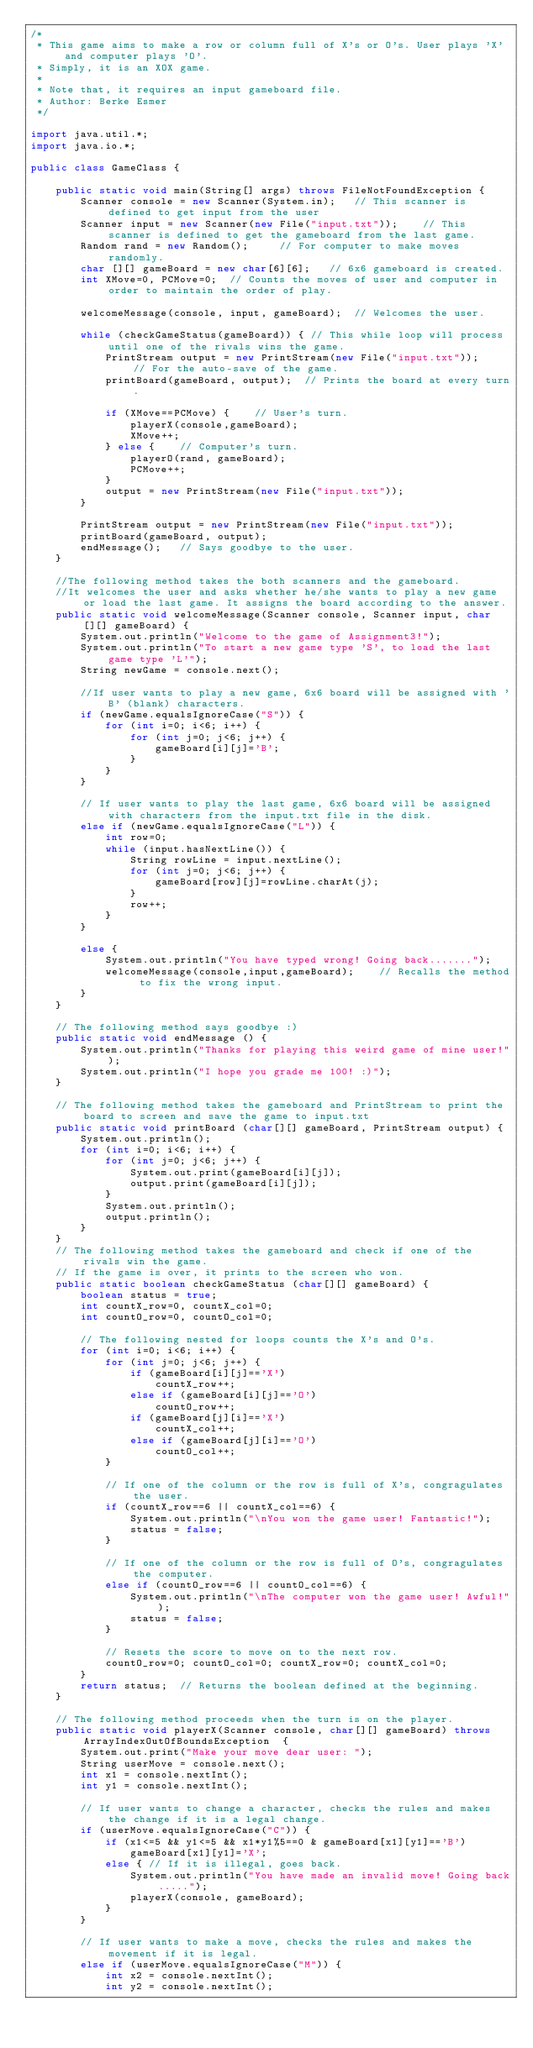<code> <loc_0><loc_0><loc_500><loc_500><_Java_>/*
 * This game aims to make a row or column full of X's or O's. User plays 'X' and computer plays 'O'.
 * Simply, it is an XOX game.
 *
 * Note that, it requires an input gameboard file.
 * Author: Berke Esmer
 */

import java.util.*;
import java.io.*;

public class GameClass {

    public static void main(String[] args) throws FileNotFoundException {
        Scanner console = new Scanner(System.in);   // This scanner is defined to get input from the user
        Scanner input = new Scanner(new File("input.txt"));    // This scanner is defined to get the gameboard from the last game.
        Random rand = new Random();		// For computer to make moves randomly.
        char [][] gameBoard = new char[6][6];	// 6x6 gameboard is created.
        int XMove=0, PCMove=0;	// Counts the moves of user and computer in order to maintain the order of play.

        welcomeMessage(console, input, gameBoard);	// Welcomes the user.

        while (checkGameStatus(gameBoard)) { // This while loop will process until one of the rivals wins the game.
            PrintStream output = new PrintStream(new File("input.txt"));	// For the auto-save of the game.
            printBoard(gameBoard, output);	// Prints the board at every turn.

            if (XMove==PCMove) {	// User's turn.
                playerX(console,gameBoard);
                XMove++;
            } else {	// Computer's turn.
                playerO(rand, gameBoard);
                PCMove++;
            }
            output = new PrintStream(new File("input.txt"));
        }

        PrintStream output = new PrintStream(new File("input.txt"));
        printBoard(gameBoard, output);
        endMessage();	// Says goodbye to the user.
    }

    //The following method takes the both scanners and the gameboard.
    //It welcomes the user and asks whether he/she wants to play a new game or load the last game. It assigns the board according to the answer.
    public static void welcomeMessage(Scanner console, Scanner input, char[][] gameBoard) {
        System.out.println("Welcome to the game of Assignment3!");
        System.out.println("To start a new game type 'S', to load the last game type 'L'");
        String newGame = console.next();

        //If user wants to play a new game, 6x6 board will be assigned with 'B' (blank) characters.
        if (newGame.equalsIgnoreCase("S")) {
            for (int i=0; i<6; i++) {
                for (int j=0; j<6; j++) {
                    gameBoard[i][j]='B';
                }
            }
        }

        // If user wants to play the last game, 6x6 board will be assigned with characters from the input.txt file in the disk.
        else if (newGame.equalsIgnoreCase("L")) {
            int row=0;
            while (input.hasNextLine()) {
                String rowLine = input.nextLine();
                for (int j=0; j<6; j++) {
                    gameBoard[row][j]=rowLine.charAt(j);
                }
                row++;
            }
        }

        else {
            System.out.println("You have typed wrong! Going back.......");
            welcomeMessage(console,input,gameBoard);	// Recalls the method to fix the wrong input.
        }
    }

    // The following method says goodbye :)
    public static void endMessage () {
        System.out.println("Thanks for playing this weird game of mine user!");
        System.out.println("I hope you grade me 100! :)");
    }

    // The following method takes the gameboard and PrintStream to print the board to screen and save the game to input.txt
    public static void printBoard (char[][] gameBoard, PrintStream output) {
        System.out.println();
        for (int i=0; i<6; i++) {
            for (int j=0; j<6; j++) {
                System.out.print(gameBoard[i][j]);
                output.print(gameBoard[i][j]);
            }
            System.out.println();
            output.println();
        }
    }
    // The following method takes the gameboard and check if one of the rivals win the game.
    // If the game is over, it prints to the screen who won.
    public static boolean checkGameStatus (char[][] gameBoard) {
        boolean status = true;
        int countX_row=0, countX_col=0;
        int countO_row=0, countO_col=0;

        // The following nested for loops counts the X's and O's.
        for (int i=0; i<6; i++) {
            for (int j=0; j<6; j++) {
                if (gameBoard[i][j]=='X')
                    countX_row++;
                else if (gameBoard[i][j]=='O')
                    countO_row++;
                if (gameBoard[j][i]=='X')
                    countX_col++;
                else if (gameBoard[j][i]=='O')
                    countO_col++;
            }

            // If one of the column or the row is full of X's, congragulates the user.
            if (countX_row==6 || countX_col==6) {
                System.out.println("\nYou won the game user! Fantastic!");
                status = false;
            }

            // If one of the column or the row is full of O's, congragulates the computer.
            else if (countO_row==6 || countO_col==6) {
                System.out.println("\nThe computer won the game user! Awful!");
                status = false;
            }

            // Resets the score to move on to the next row.
            countO_row=0; countO_col=0; countX_row=0; countX_col=0;
        }
        return status;	// Returns the boolean defined at the beginning.
    }

    // The following method proceeds when the turn is on the player.
    public static void playerX(Scanner console, char[][] gameBoard) throws ArrayIndexOutOfBoundsException  {
        System.out.print("Make your move dear user: ");
        String userMove = console.next();
        int x1 = console.nextInt();
        int y1 = console.nextInt();

        // If user wants to change a character, checks the rules and makes the change if it is a legal change.
        if (userMove.equalsIgnoreCase("C")) {
            if (x1<=5 && y1<=5 && x1*y1%5==0 & gameBoard[x1][y1]=='B')
                gameBoard[x1][y1]='X';
            else { // If it is illegal, goes back.
                System.out.println("You have made an invalid move! Going back.....");
                playerX(console, gameBoard);
            }
        }

        // If user wants to make a move, checks the rules and makes the movement if it is legal.
        else if (userMove.equalsIgnoreCase("M")) {
            int x2 = console.nextInt();
            int y2 = console.nextInt();</code> 